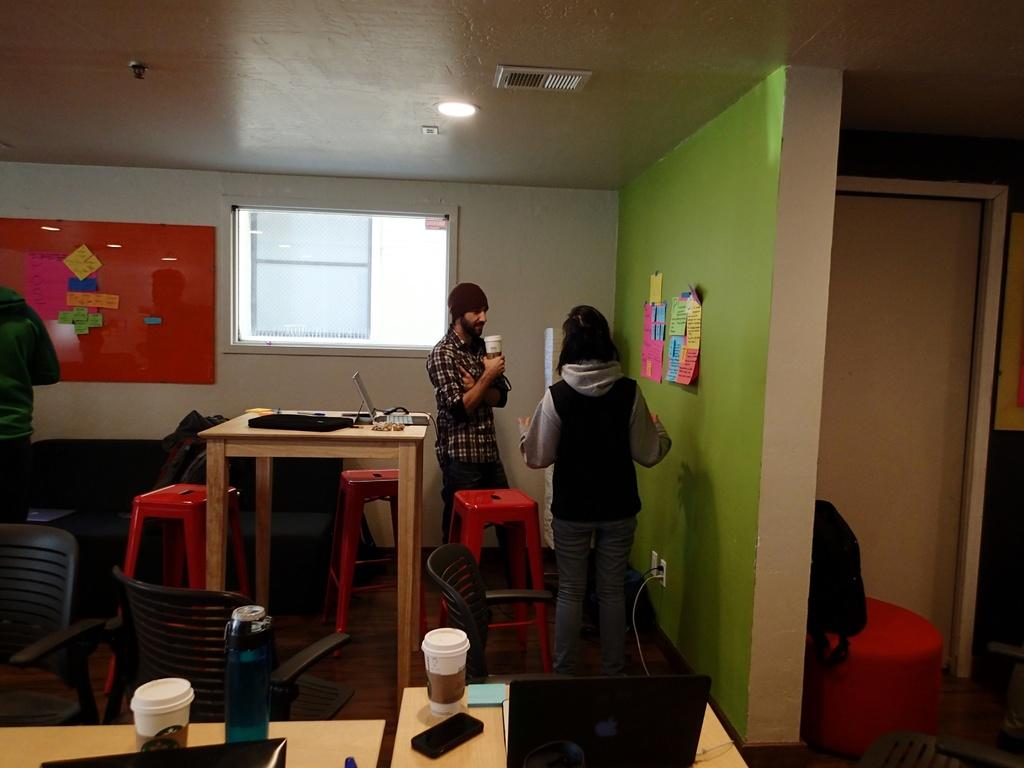How many people are in the image? There are two persons in the image. What is the background of the image? The persons are standing in front of a green wall. What is attached to the green wall? There are papers pasted on the green wall. What is located behind the persons? There is a table behind the persons. What can be found on the table? There are objects on the table. What type of blade can be seen in the image? There is no blade present in the image. What color are the lips of the person on the left? There is no person on the left, and no lips are visible in the image. 